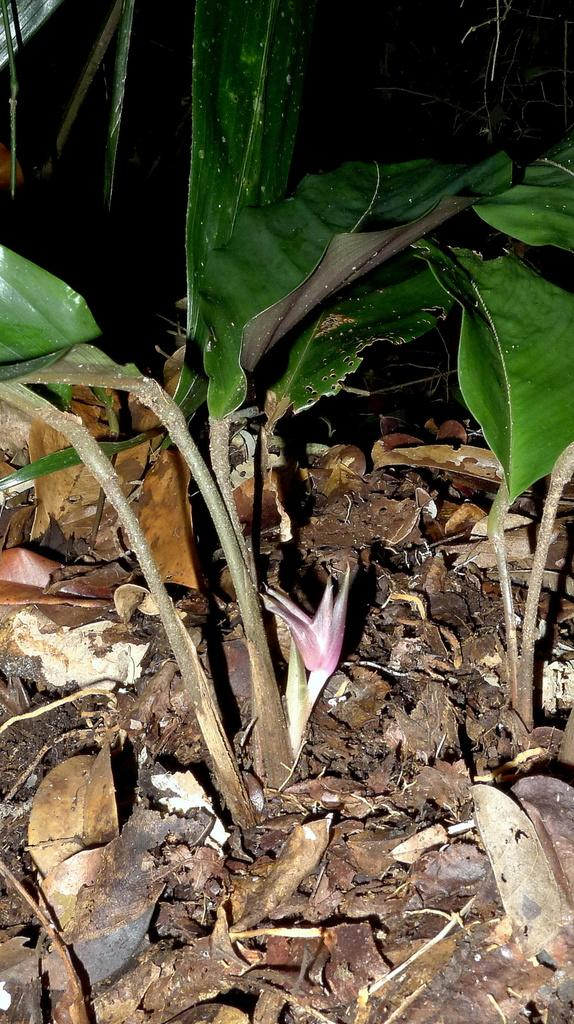What is: What type of plant can be seen in the image? There is a plant in the image. What can be observed on the ground in the image? Dry leaves are present on the ground in the image. What type of invention is being used to harvest the apples in the image? There are no apples or any invention related to harvesting apples present in the image. 